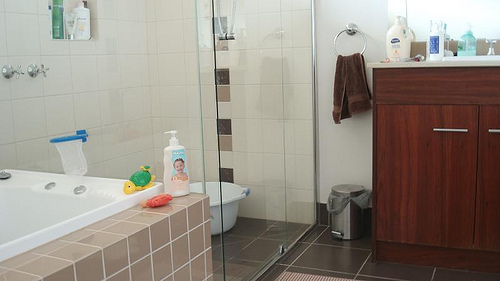Please provide a short description for this region: [0.1, 0.47, 0.39, 0.63]. A corner of the tub with various toys and shampoo bottles neatly arranged. 